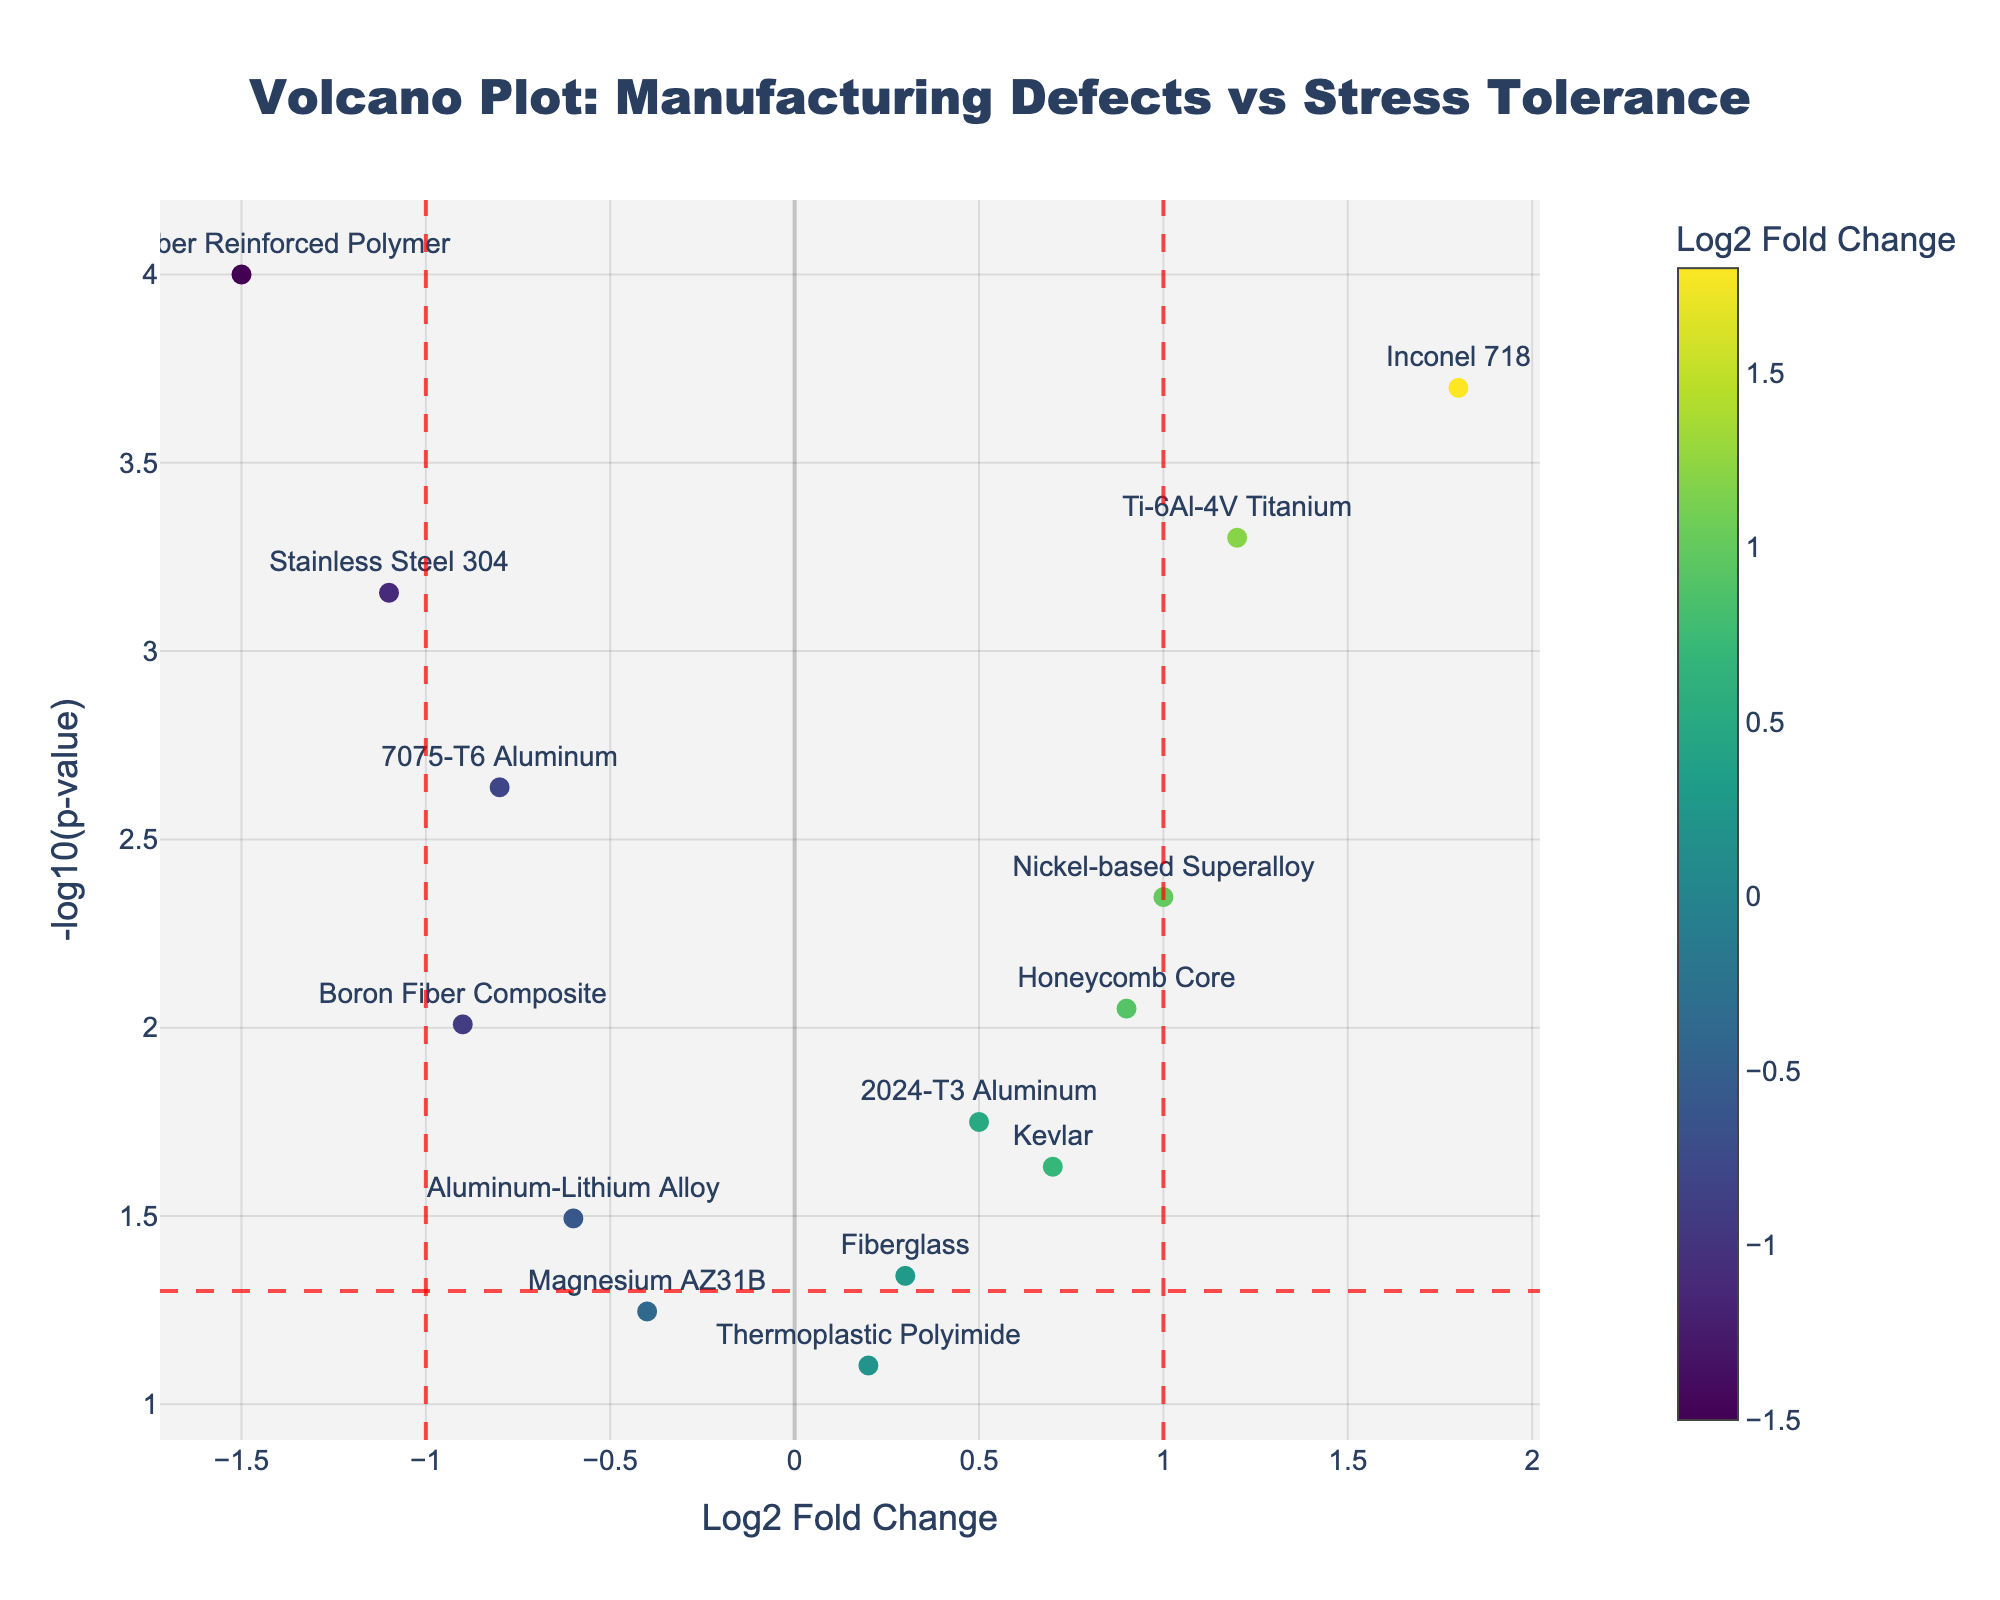What's the title of the volcano plot? The title is typically located at the top center of the plot. It reads 'Volcano Plot: Manufacturing Defects vs Stress Tolerance'.
Answer: Volcano Plot: Manufacturing Defects vs Stress Tolerance Which material has the highest log2 fold change? To find this, we look for the data point on the x-axis with the highest positive value for log2 fold change. Inconel 718 has a log2 fold change of 1.8, which is the highest.
Answer: Inconel 718 How many materials have a log2 fold change greater than 0? We count the number of data points to the right of the y-axis (log2 fold change > 0). These materials are 2024-T3 Aluminum, Ti-6Al-4V Titanium, Honeycomb Core, Kevlar, Inconel 718, Nickel-based Superalloy, and Thermoplastic Polyimide.
Answer: 7 Which material has the most negative log2 fold change? We look for the data point on the x-axis with the lowest (most negative) value for log2 fold change. Carbon Fiber Reinforced Polymer has a log2 fold change of -1.5, which is the most negative.
Answer: Carbon Fiber Reinforced Polymer How many materials are considered statistically significant with a p-value threshold of 0.05? A p-value of 0.05 corresponds to a -log10(p-value) of 1.3. We count the number of points above this threshold on the y-axis. These materials are 7075-T6 Aluminum, Ti-6Al-4V Titanium, Carbon Fiber Reinforced Polymer, Stainless Steel 304, Honeycomb Core, Inconel 718, Nickel-based Superalloy, and Boron Fiber Composite.
Answer: 8 Which materials fall into the region of interest for high stress tolerance and low manufacturing defects (defined by log2 fold change > 1 and p-value < 0.05)? We look for data points with x-axis > 1 and y-axis > 1.3. These materials are Ti-6Al-4V Titanium and Inconel 718.
Answer: Ti-6Al-4V Titanium, Inconel 718 What is the -log10(p-value) for Carbon Fiber Reinforced Polymer? We find the data point labeled Carbon Fiber Reinforced Polymer and look at its y-axis value. The -log10(p-value) is -log10(0.0001) = 4.
Answer: 4 Which material is closest to the origin (0,0)? We find the data point with values closest to (0,0). Thermoplastic Polyimide has the coordinates (0.2, -log10(0.0789) ≈ 1.10), which is closest to the origin.
Answer: Thermoplastic Polyimide Which material with log2 fold change < 0 has the most significant p-value? For materials with log2 fold change < 0, we look for the highest y-axis value, which corresponds to the most significant p-value. Carbon Fiber Reinforced Polymer has the highest y-value of 4.
Answer: Carbon Fiber Reinforced Polymer 